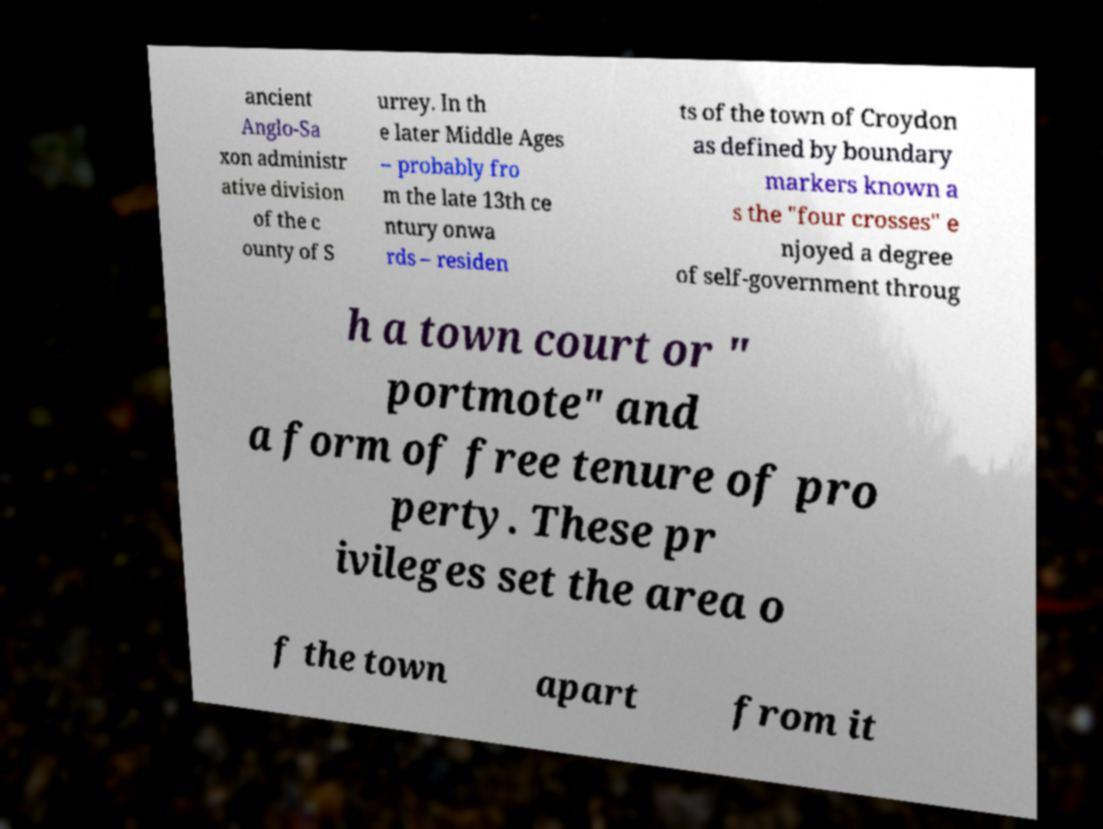Can you accurately transcribe the text from the provided image for me? ancient Anglo-Sa xon administr ative division of the c ounty of S urrey. In th e later Middle Ages – probably fro m the late 13th ce ntury onwa rds – residen ts of the town of Croydon as defined by boundary markers known a s the "four crosses" e njoyed a degree of self-government throug h a town court or " portmote" and a form of free tenure of pro perty. These pr ivileges set the area o f the town apart from it 